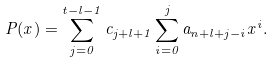<formula> <loc_0><loc_0><loc_500><loc_500>P ( x ) = \sum _ { j = 0 } ^ { t - l - 1 } c _ { j + l + 1 } \sum _ { i = 0 } ^ { j } a _ { n + l + j - i } x ^ { i } .</formula> 